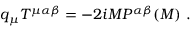Convert formula to latex. <formula><loc_0><loc_0><loc_500><loc_500>q _ { \mu } T ^ { \mu \alpha \beta } = - 2 i M P ^ { \alpha \beta } ( M ) .</formula> 